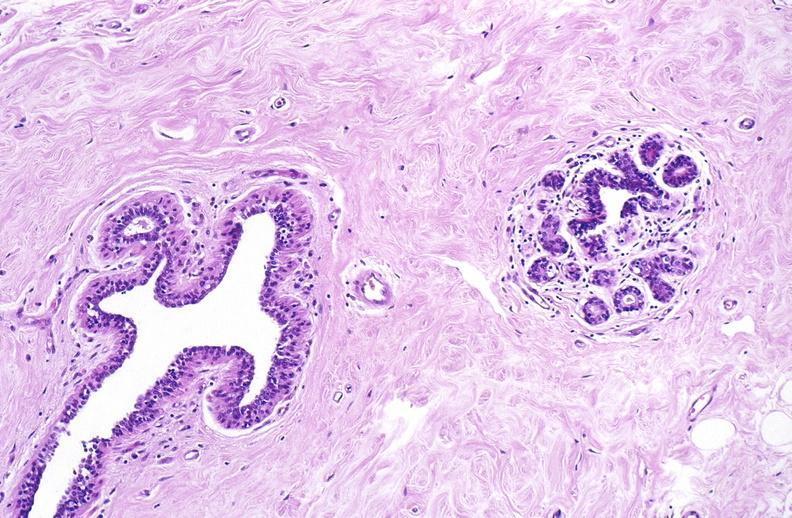what does this image show?
Answer the question using a single word or phrase. Normal breast 